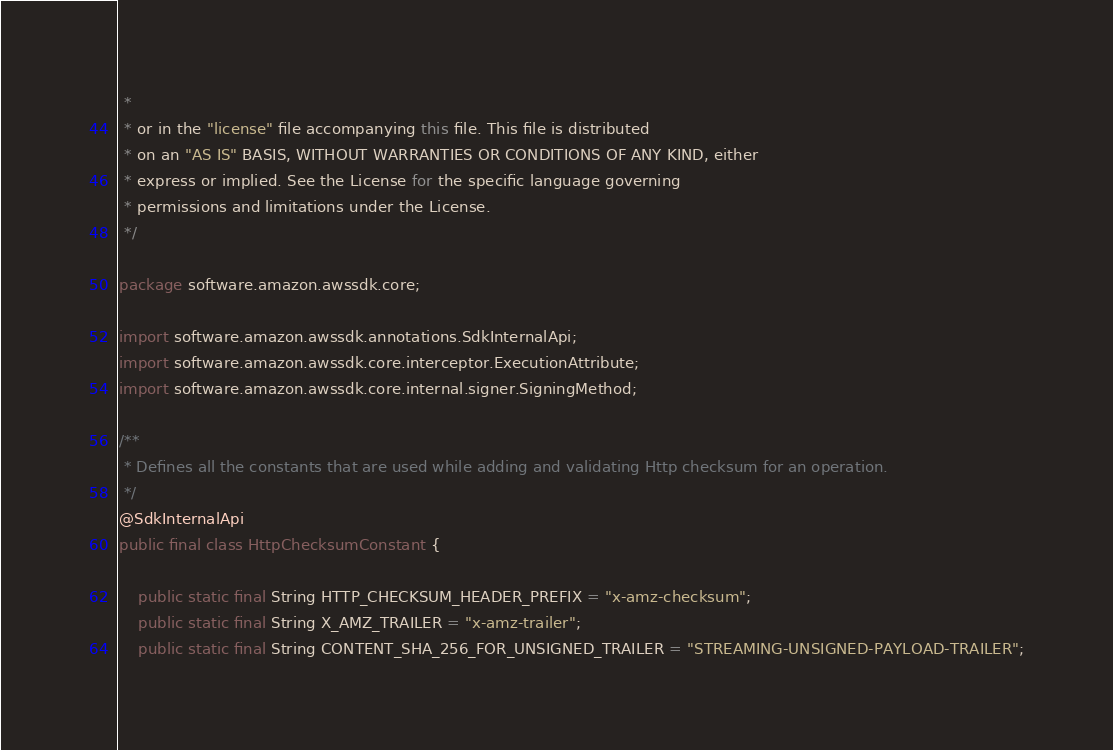<code> <loc_0><loc_0><loc_500><loc_500><_Java_> *
 * or in the "license" file accompanying this file. This file is distributed
 * on an "AS IS" BASIS, WITHOUT WARRANTIES OR CONDITIONS OF ANY KIND, either
 * express or implied. See the License for the specific language governing
 * permissions and limitations under the License.
 */

package software.amazon.awssdk.core;

import software.amazon.awssdk.annotations.SdkInternalApi;
import software.amazon.awssdk.core.interceptor.ExecutionAttribute;
import software.amazon.awssdk.core.internal.signer.SigningMethod;

/**
 * Defines all the constants that are used while adding and validating Http checksum for an operation.
 */
@SdkInternalApi
public final class HttpChecksumConstant {

    public static final String HTTP_CHECKSUM_HEADER_PREFIX = "x-amz-checksum";
    public static final String X_AMZ_TRAILER = "x-amz-trailer";
    public static final String CONTENT_SHA_256_FOR_UNSIGNED_TRAILER = "STREAMING-UNSIGNED-PAYLOAD-TRAILER";
</code> 